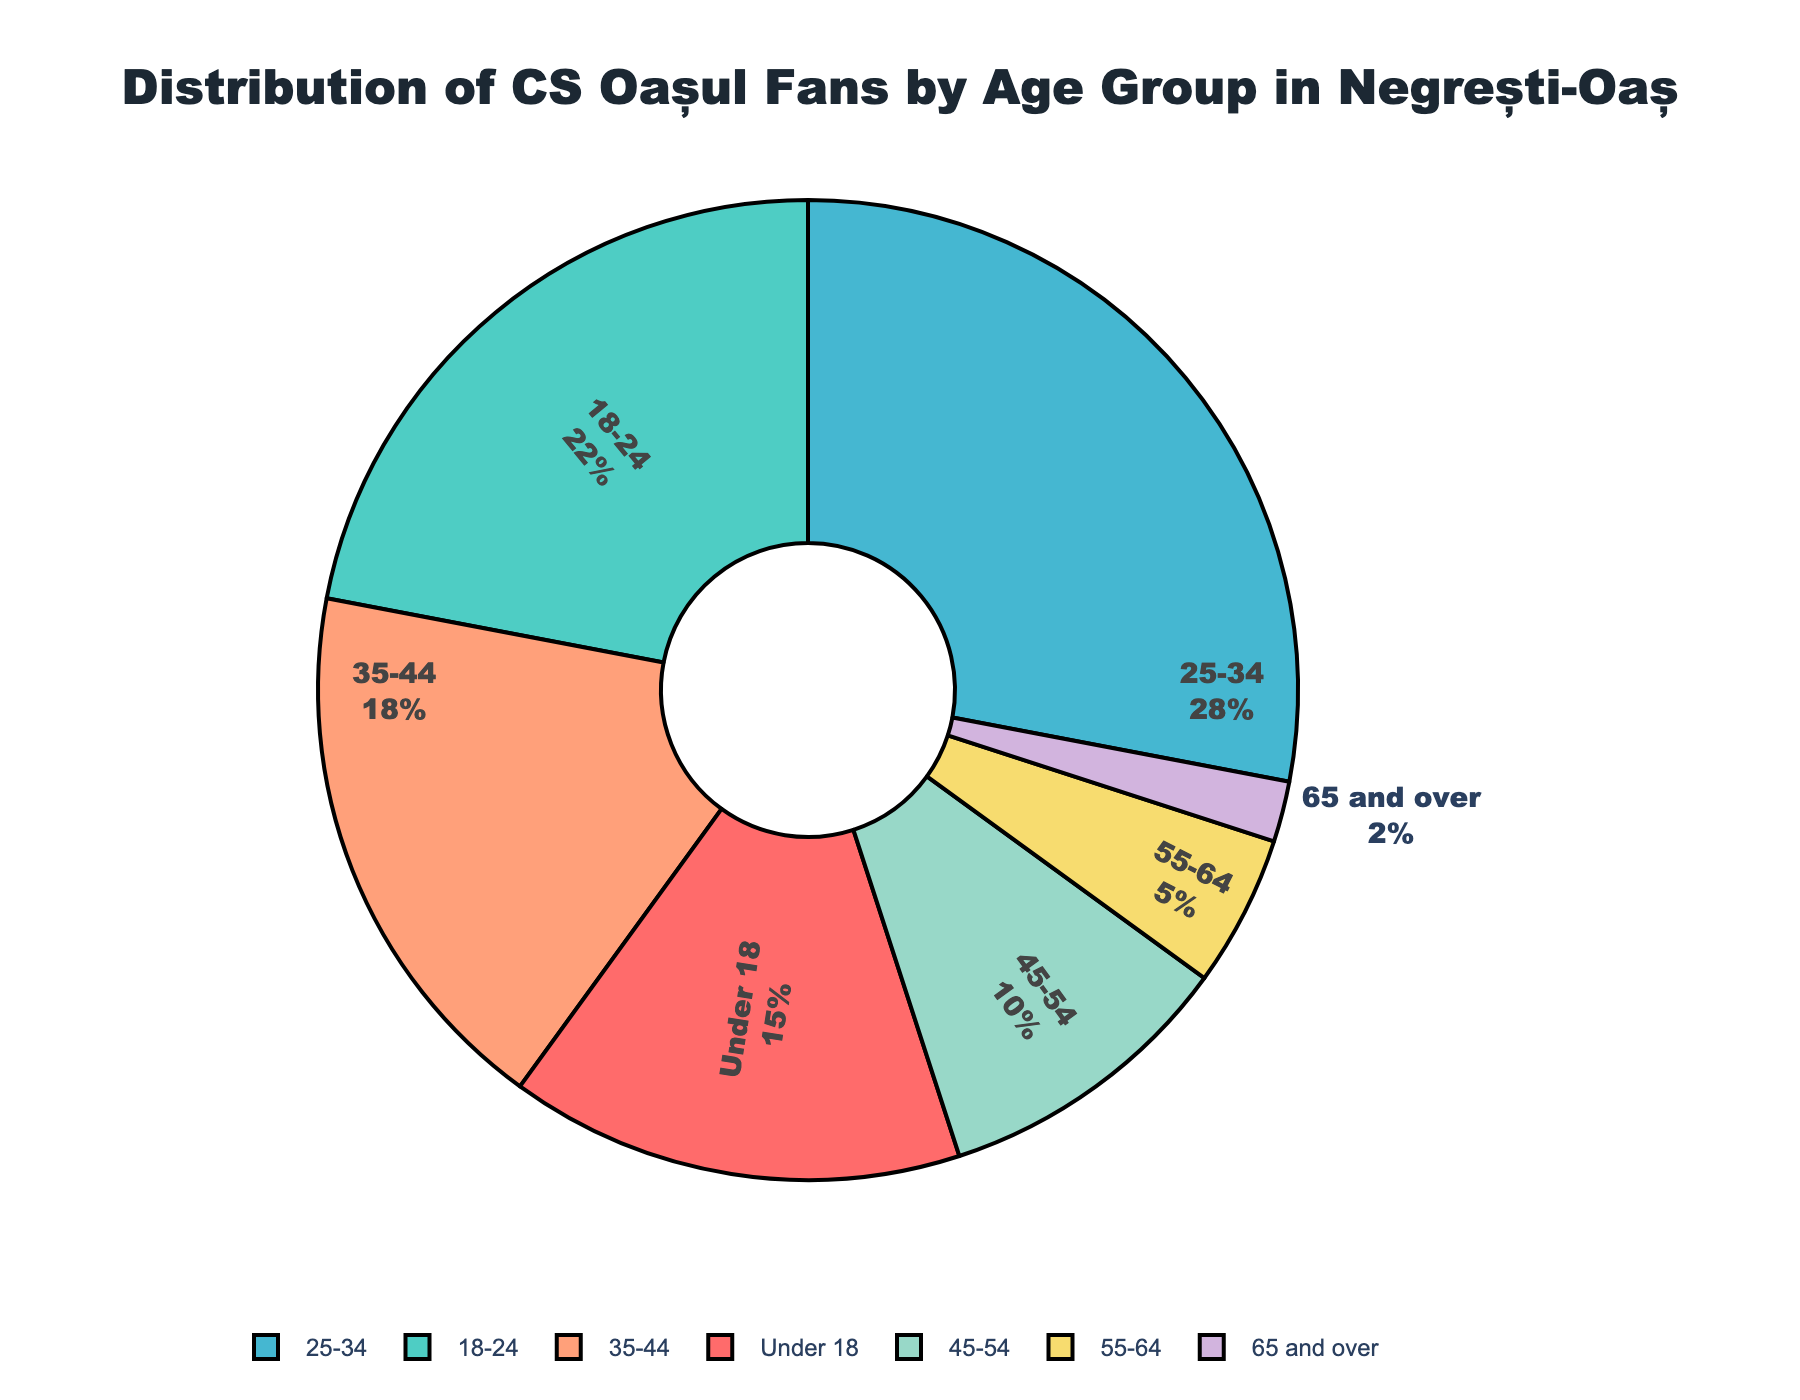What age group has the highest percentage of CS Oașul fans? The pie chart shows different age groups represented by different colors. The 25-34 age group appears to have the largest section of the pie.
Answer: 25-34 Which age group has a lower percentage of fans, 45-54 or 55-64? Compare the sizes of the sections corresponding to the 45-54 and 55-64 age groups. The slice for 55-64 is smaller.
Answer: 55-64 What is the combined percentage of CS Oașul fans aged 35-44 and 45-54? Add the percentages for the 35-44 and 45-54 age groups: 18% + 10% = 28%.
Answer: 28% Which age groups have a fan percentage greater than 15%? Identify the age groups from the pie chart with percentages greater than 15%. These are Under 18 (15%), 18-24 (22%), 25-34 (28%), and 35-44 (18%).
Answer: 18-24, 25-34, 35-44 How much larger is the percentage of CS Oașul fans in the 25-34 age group compared to the 18-24 age group? Subtract the 18-24 group percentage from the 25-34 group percentage: 28% - 22% = 6%.
Answer: 6% What color represents the Under 18 age group in the pie chart? Check the color used for the Under 18 slice in the pie chart. It appears as red.
Answer: Red What is the total percentage of CS Oașul fans that are over 44 years old? Add the percentages of the 45-54, 55-64, and 65 and over age groups: 10% + 5% + 2% = 17%.
Answer: 17% Which age group has exactly twice the percentage of the 65 and over age group? The 65 and over group has 2%, so twice that would be 4%. No group has exactly 4%; consider 5% (55-64), which is close.
Answer: None If you were to combine the fans of the youngest and oldest age groups, what percentage would they represent? Add the percentages of the Under 18 and 65 and over groups: 15% + 2% = 17%.
Answer: 17% 